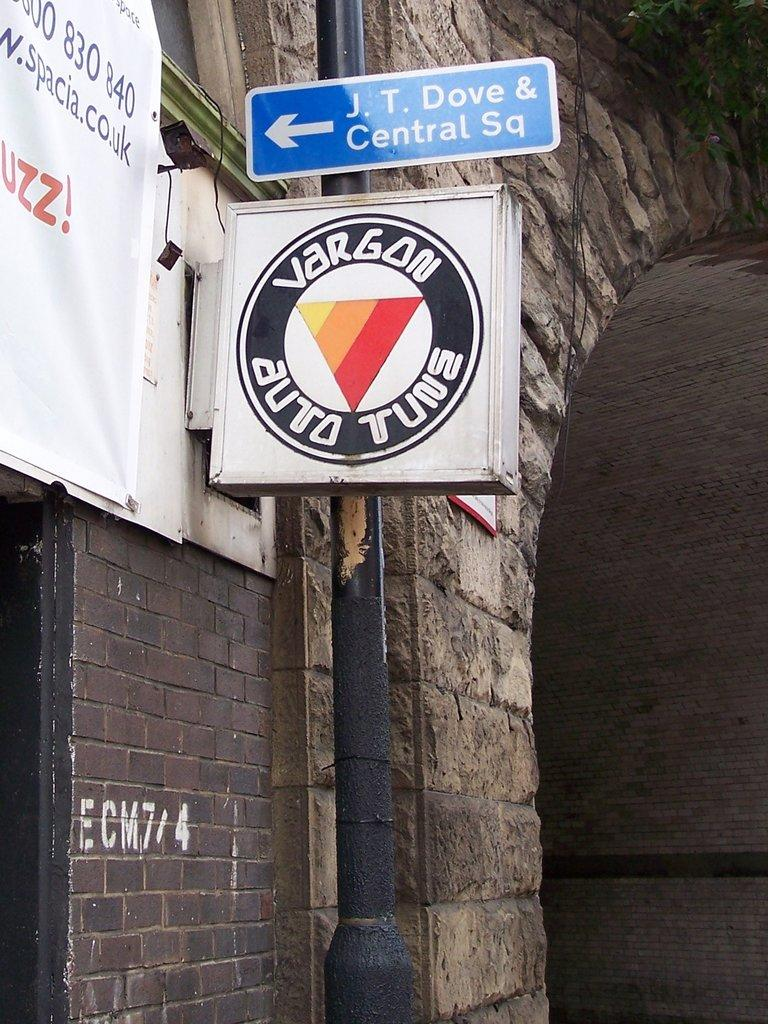<image>
Relay a brief, clear account of the picture shown. An outdoor sign for Vargon Auto is displayed. 